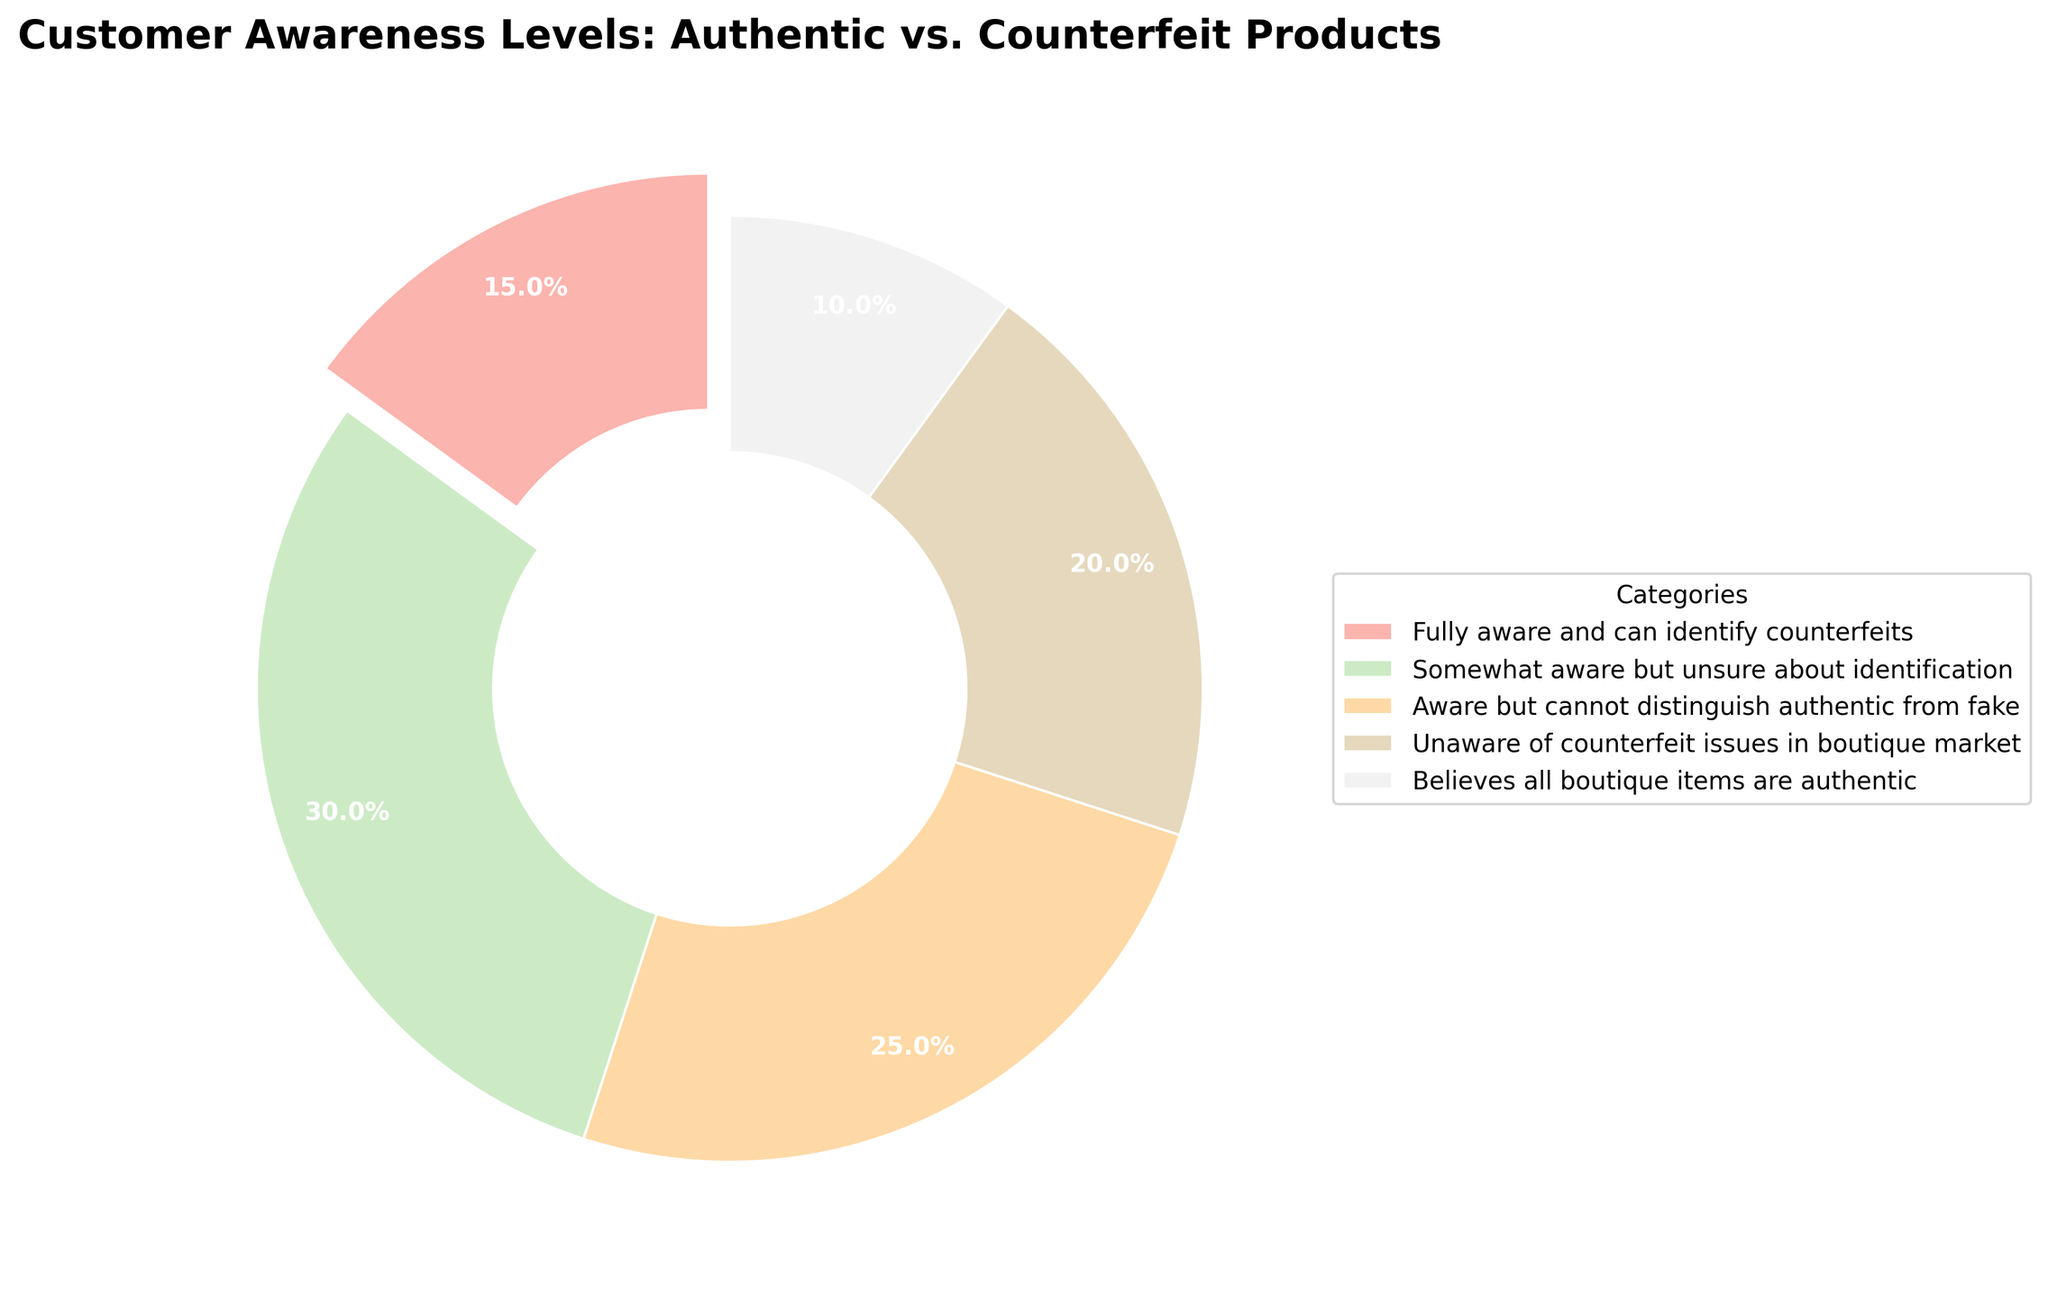What percentage of customers are fully aware and can identify counterfeits? The pie chart shows a segment labeled "Fully aware and can identify counterfeits," with a percentage value displayed.
Answer: 15% What is the combined percentage of customers who are either somewhat aware but unsure about identification or aware but cannot distinguish authentic from fake? The pie chart has segments labeled "Somewhat aware but unsure about identification" and "Aware but cannot distinguish authentic from fake" with percentages. Add these two values together: 30% + 25%.
Answer: 55% Which category has the lowest percentage of customer awareness? The pie chart displays percentages for different categories. The lowest percentage is for "Believes all boutique items are authentic."
Answer: 10% What is the total percentage of customers who are aware (either fully, somewhat, or aware but can't distinguish) about counterfeit issues? Add the percentages of the categories: "Fully aware and can identify counterfeits" (15%), "Somewhat aware but unsure about identification" (30%), and "Aware but cannot distinguish authentic from fake" (25%). 15% + 30% + 25% = 70%.
Answer: 70% Is the percentage of customers who are unaware of counterfeit issues higher than the percentage who believe all boutique items are authentic? Compare the segments labeled "Unaware of counterfeit issues in boutique market" (20%) with "Believes all boutique items are authentic" (10%).
Answer: Yes Which category's segment is visually highlighted in the pie chart? The pie chart segment that is visually highlighted (exploded segment) represents the category "Fully aware and can identify counterfeits."
Answer: Fully aware and can identify counterfeits What is the difference in percentage between customers who are fully aware and those who are somewhat aware but unsure about identification? Subtract the percentage of "Fully aware and can identify counterfeits" (15%) from "Somewhat aware but unsure about identification" (30%). 30% - 15%.
Answer: 15% Which two categories together account for 30% of the customer awareness levels? Analyze the percentages of each segment. The categories "Unaware of counterfeit issues in boutique market" (20%) and "Believes all boutique items are authentic" (10%) sum to 30%.
Answer: Unaware of counterfeit issues in boutique market and Believes all boutique items are authentic 